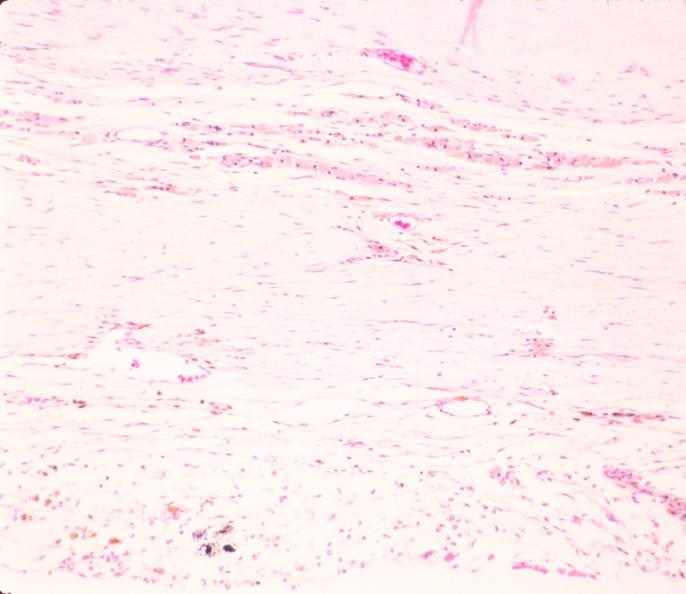where is this?
Answer the question using a single word or phrase. Nervous 